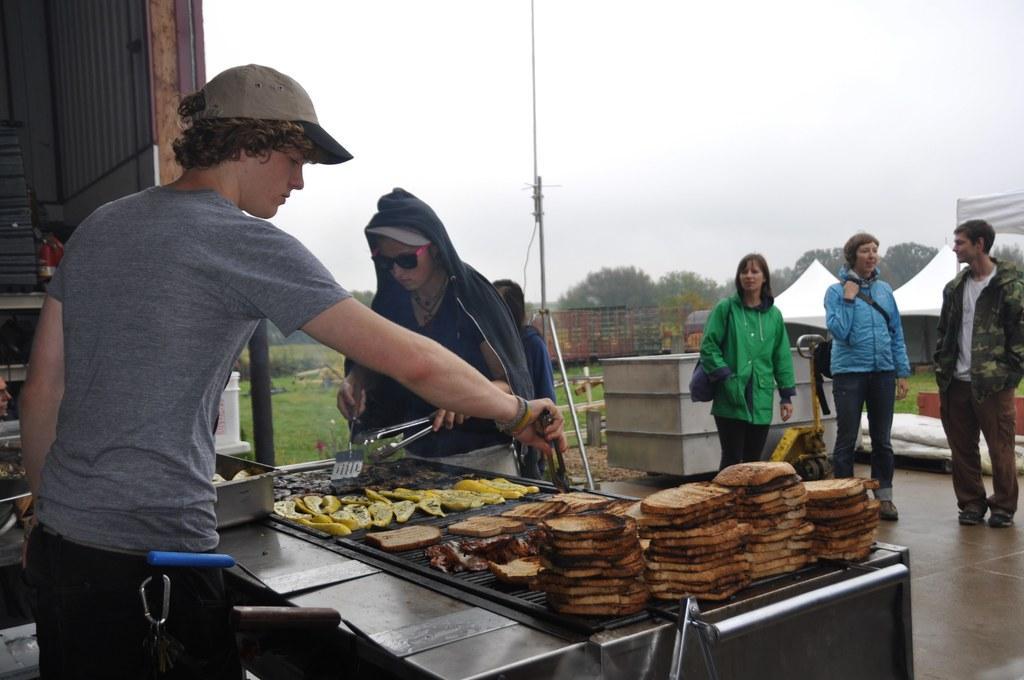Please provide a concise description of this image. In this picture we can see some people are standing, a person on the left side is holding a spoon, there is a grill stand in front of him, we can see some food on grill stand, in the background we can see grass, plants, trees, a pole and two tents, there is the sky at the top of the picture. 